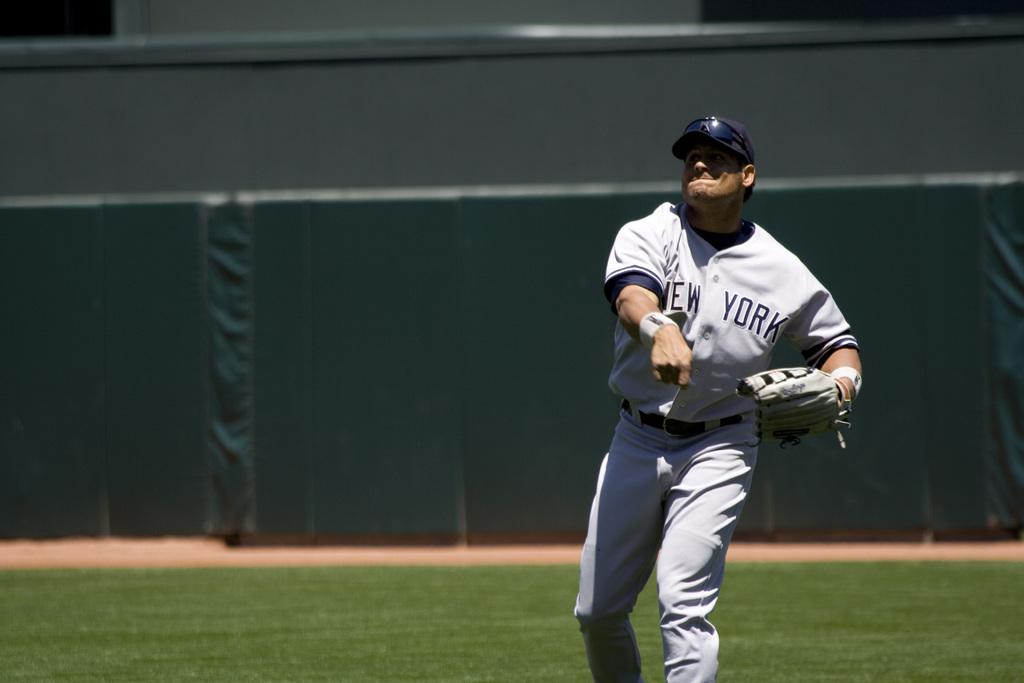<image>
Summarize the visual content of the image. A person wearing a New York jersey throws a baseball. 